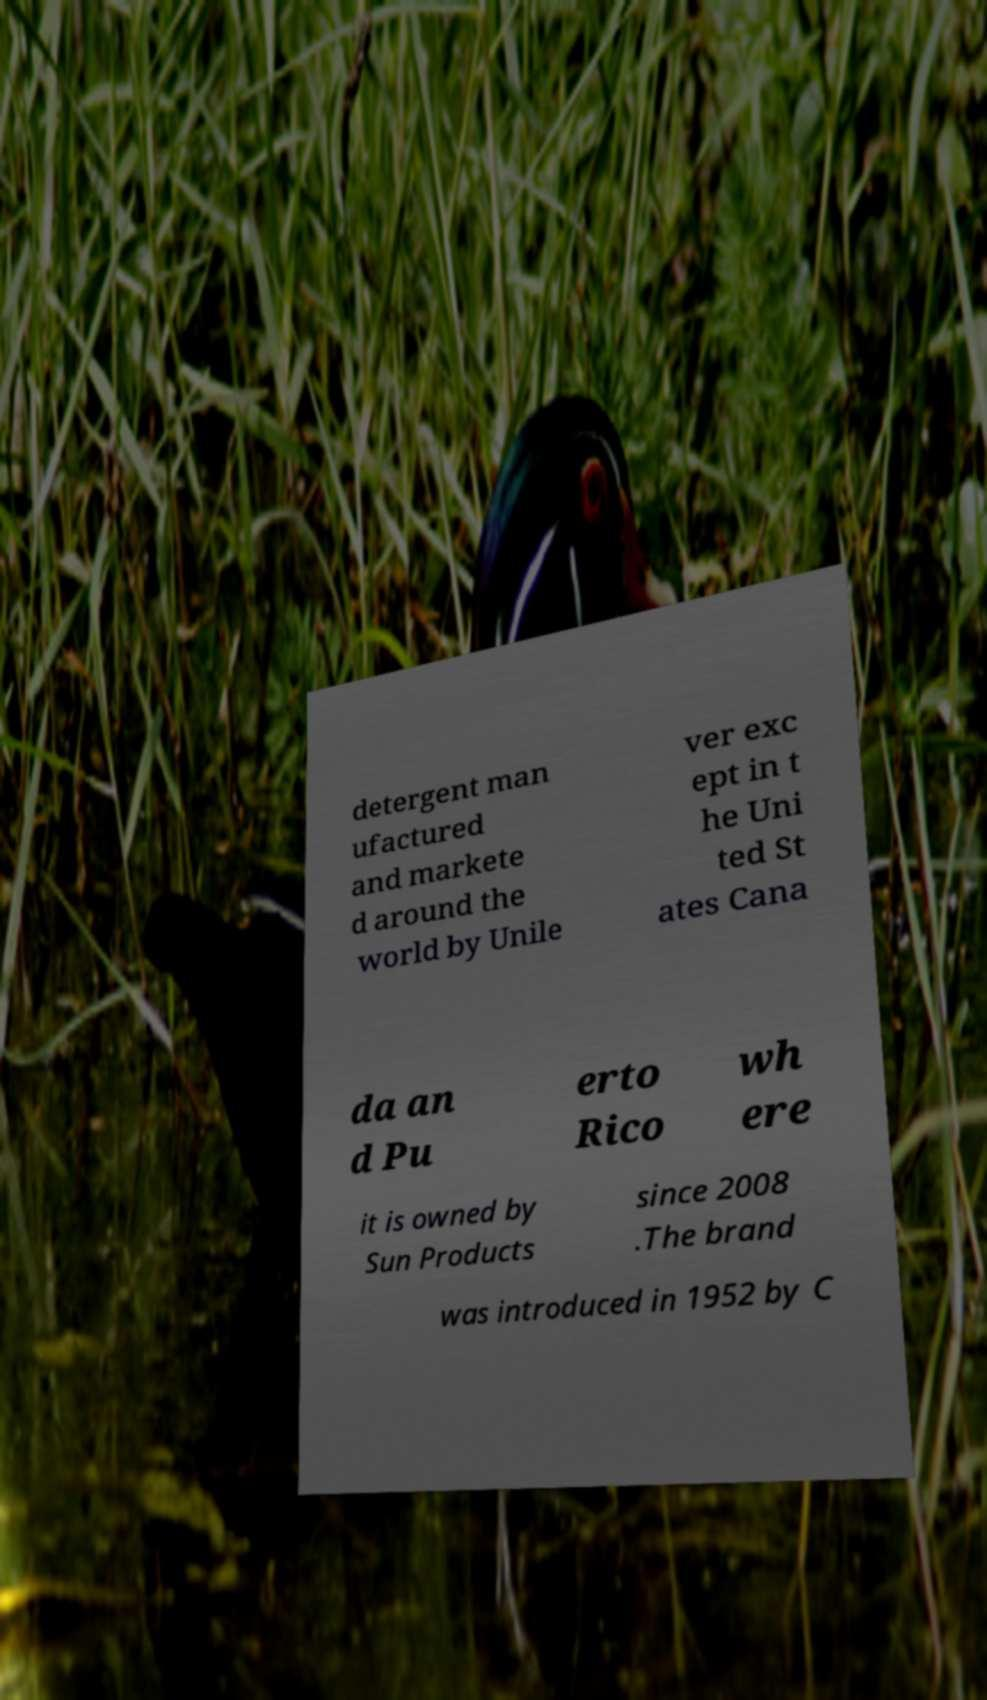I need the written content from this picture converted into text. Can you do that? detergent man ufactured and markete d around the world by Unile ver exc ept in t he Uni ted St ates Cana da an d Pu erto Rico wh ere it is owned by Sun Products since 2008 .The brand was introduced in 1952 by C 